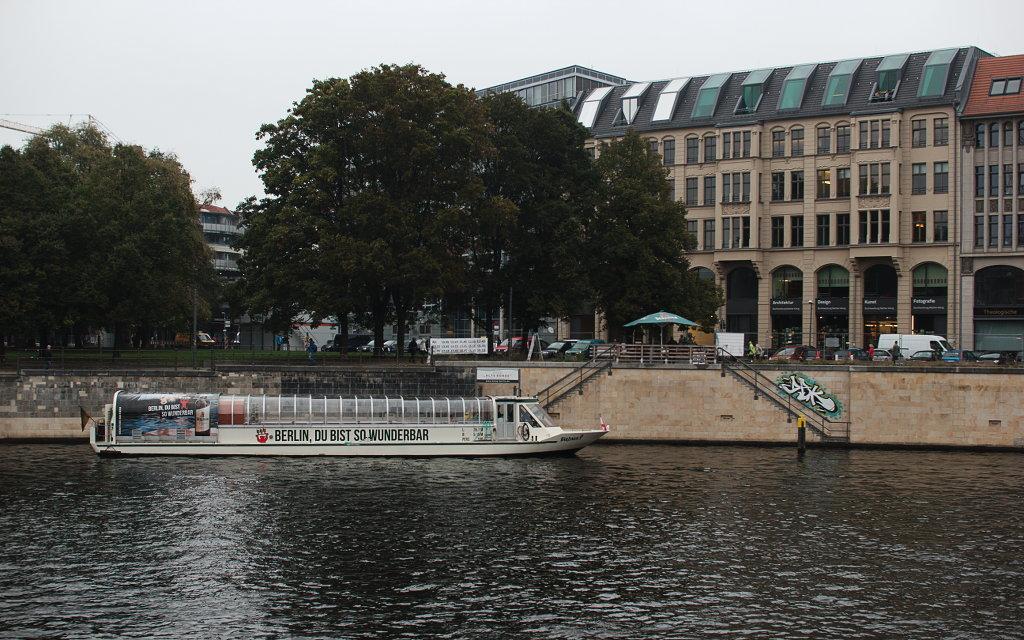Please provide a concise description of this image. At the bottom of this image I can see the water and there is a boat. In the middle of the image there are many vehicles on the road. In the background there are many trees and buildings. On the left side, I can see few people on the road and there are staircases to the wall. At the top of the image I can see the sky. 